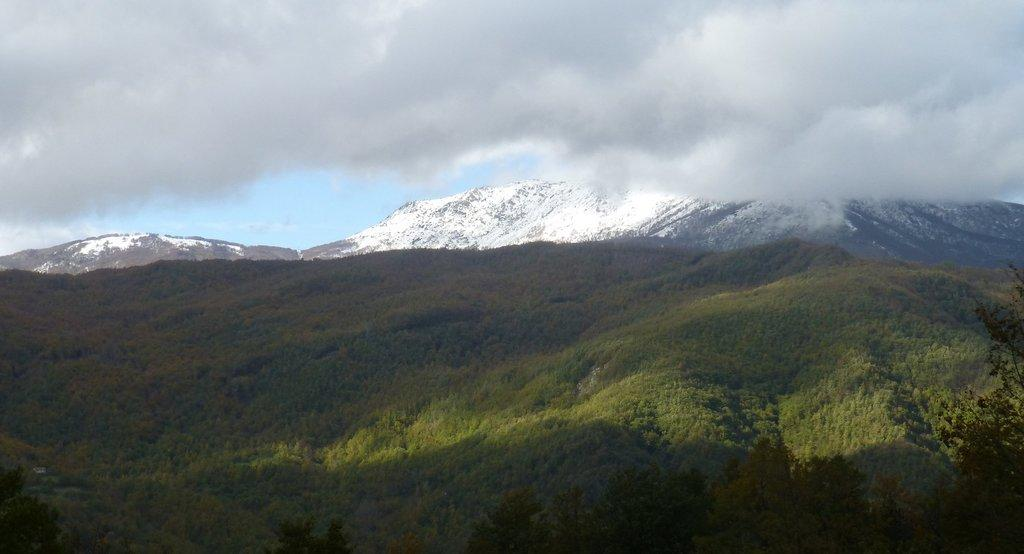What type of vegetation is at the bottom of the image? There are trees at the bottom of the image. What can be seen in the background of the image? There are hills with snow in the background of the image. What is the condition of the sky in the image? The sky is cloudy at the top of the image. What type of hearing aid is visible in the image? There is no hearing aid present in the image. How does the wilderness in the image contribute to the overall atmosphere? There is no wilderness present in the image; it features trees, hills, and a cloudy sky. What type of selection process is depicted in the image? There is no selection process depicted in the image. 